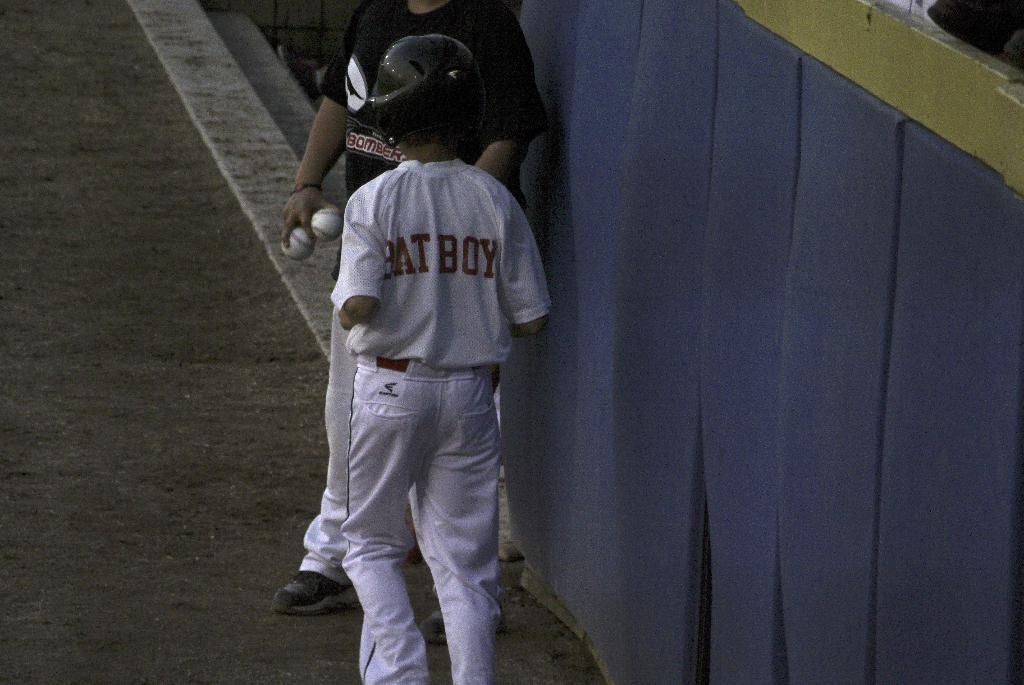How many people are in the image? There are two people in the image. What is the position of the people in the image? The people are on the ground. What objects can be seen in the image besides the people? There are balls and some other objects in the image. Is there any smoke visible in the image? No, there is no smoke present in the image. What type of animal can be seen interacting with the people in the image? There is no animal, such as a donkey, present in the image. 